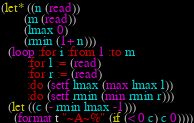<code> <loc_0><loc_0><loc_500><loc_500><_Lisp_>(let* ((n (read))
       (m (read))
       (lmax 0)
       (rmin (1+ n)))
  (loop :for i :from 1 :to m
        :for l := (read)
        :for r := (read)
        :do (setf lmax (max lmax l))
        :do (setf rmin (min rmin r)))
  (let ((c (- rmin lmax -1)))
    (format t "~A~%" (if (< 0 c) c 0))))
</code> 